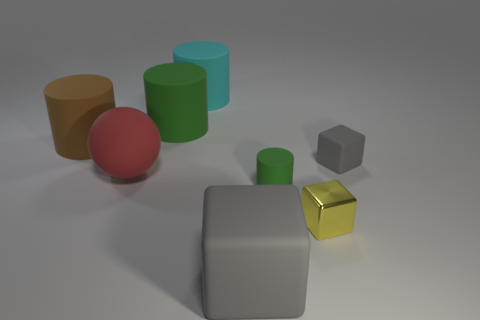Add 2 small red matte balls. How many objects exist? 10 Subtract all cubes. How many objects are left? 5 Add 6 small cubes. How many small cubes are left? 8 Add 2 tiny yellow shiny things. How many tiny yellow shiny things exist? 3 Subtract 0 brown cubes. How many objects are left? 8 Subtract all big purple things. Subtract all cyan rubber cylinders. How many objects are left? 7 